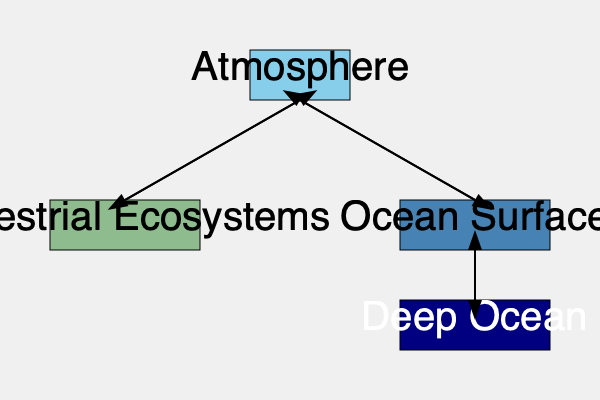In the carbon cycle flowchart, which component acts as both a source and a sink for atmospheric carbon dioxide, and how might this impact environmental career opportunities? To answer this question, let's analyze the carbon cycle flowchart step-by-step:

1. The flowchart shows four main components: Atmosphere, Terrestrial Ecosystems, Ocean Surface, and Deep Ocean.

2. We can see bidirectional arrows between the Atmosphere and two other components:
   a) Terrestrial Ecosystems
   b) Ocean Surface

3. These bidirectional arrows indicate that both Terrestrial Ecosystems and Ocean Surface can act as both sources and sinks for atmospheric carbon dioxide.

4. Terrestrial Ecosystems:
   - Act as a sink through photosynthesis, absorbing CO₂ from the atmosphere.
   - Act as a source through respiration and decomposition, releasing CO₂ back into the atmosphere.

5. Ocean Surface:
   - Acts as a sink by absorbing CO₂ from the atmosphere through dissolution.
   - Acts as a source by releasing CO₂ back into the atmosphere through outgassing.

6. Impact on environmental career opportunities:
   - Understanding these dual roles is crucial for careers in climate science, conservation, and environmental management.
   - It opens up opportunities in:
     a) Forest management and reforestation projects
     b) Ocean conservation and marine ecosystem management
     c) Climate change mitigation strategies
     d) Carbon sequestration technologies
     e) Environmental policy and regulation

7. As an environmental career counselor, this knowledge allows you to guide clients towards diverse career paths that focus on managing and optimizing these natural carbon sinks and sources.

Given the question's focus on both source and sink roles, as well as the environmental career aspect, the most comprehensive answer would be Terrestrial Ecosystems.
Answer: Terrestrial Ecosystems 